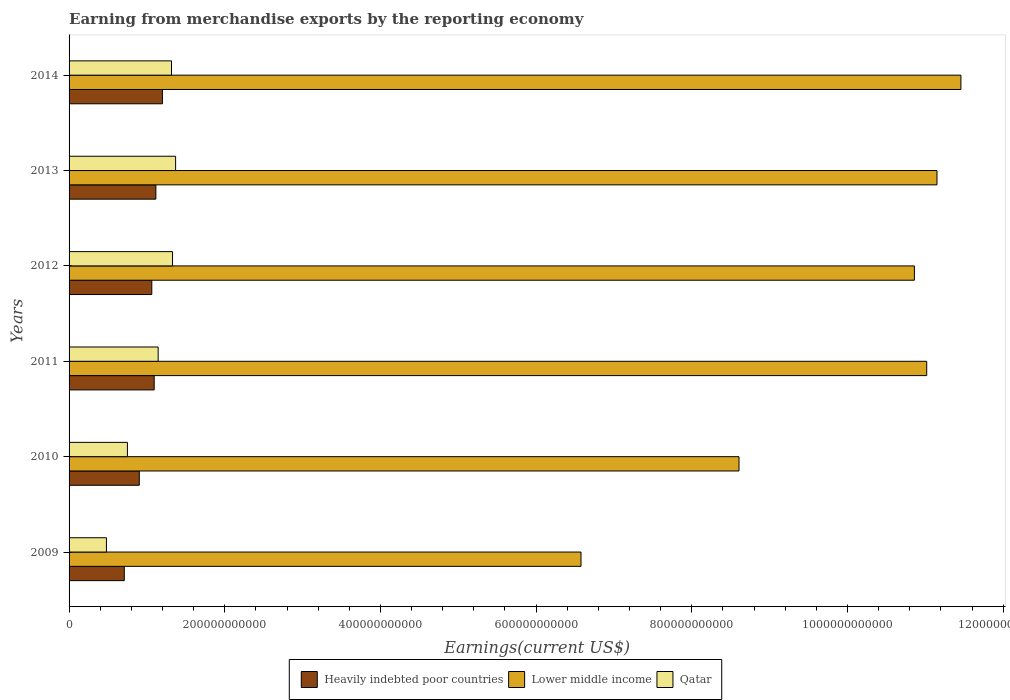How many groups of bars are there?
Offer a terse response. 6. Are the number of bars on each tick of the Y-axis equal?
Your answer should be very brief. Yes. How many bars are there on the 5th tick from the top?
Your answer should be compact. 3. In how many cases, is the number of bars for a given year not equal to the number of legend labels?
Keep it short and to the point. 0. What is the amount earned from merchandise exports in Lower middle income in 2013?
Offer a very short reply. 1.11e+12. Across all years, what is the maximum amount earned from merchandise exports in Lower middle income?
Provide a succinct answer. 1.15e+12. Across all years, what is the minimum amount earned from merchandise exports in Lower middle income?
Give a very brief answer. 6.58e+11. What is the total amount earned from merchandise exports in Lower middle income in the graph?
Keep it short and to the point. 5.97e+12. What is the difference between the amount earned from merchandise exports in Heavily indebted poor countries in 2011 and that in 2012?
Offer a very short reply. 3.08e+09. What is the difference between the amount earned from merchandise exports in Lower middle income in 2010 and the amount earned from merchandise exports in Heavily indebted poor countries in 2009?
Your answer should be compact. 7.90e+11. What is the average amount earned from merchandise exports in Qatar per year?
Your answer should be very brief. 1.06e+11. In the year 2011, what is the difference between the amount earned from merchandise exports in Lower middle income and amount earned from merchandise exports in Qatar?
Provide a succinct answer. 9.87e+11. What is the ratio of the amount earned from merchandise exports in Heavily indebted poor countries in 2013 to that in 2014?
Offer a very short reply. 0.93. Is the amount earned from merchandise exports in Lower middle income in 2011 less than that in 2013?
Make the answer very short. Yes. Is the difference between the amount earned from merchandise exports in Lower middle income in 2009 and 2012 greater than the difference between the amount earned from merchandise exports in Qatar in 2009 and 2012?
Make the answer very short. No. What is the difference between the highest and the second highest amount earned from merchandise exports in Qatar?
Provide a succinct answer. 3.96e+09. What is the difference between the highest and the lowest amount earned from merchandise exports in Qatar?
Provide a short and direct response. 8.89e+1. What does the 2nd bar from the top in 2012 represents?
Your answer should be compact. Lower middle income. What does the 1st bar from the bottom in 2013 represents?
Offer a very short reply. Heavily indebted poor countries. Is it the case that in every year, the sum of the amount earned from merchandise exports in Heavily indebted poor countries and amount earned from merchandise exports in Lower middle income is greater than the amount earned from merchandise exports in Qatar?
Offer a terse response. Yes. How many bars are there?
Keep it short and to the point. 18. What is the difference between two consecutive major ticks on the X-axis?
Offer a terse response. 2.00e+11. Where does the legend appear in the graph?
Your answer should be compact. Bottom center. What is the title of the graph?
Your response must be concise. Earning from merchandise exports by the reporting economy. Does "Brazil" appear as one of the legend labels in the graph?
Provide a succinct answer. No. What is the label or title of the X-axis?
Give a very brief answer. Earnings(current US$). What is the label or title of the Y-axis?
Provide a short and direct response. Years. What is the Earnings(current US$) of Heavily indebted poor countries in 2009?
Your response must be concise. 7.09e+1. What is the Earnings(current US$) in Lower middle income in 2009?
Keep it short and to the point. 6.58e+11. What is the Earnings(current US$) of Qatar in 2009?
Ensure brevity in your answer.  4.80e+1. What is the Earnings(current US$) of Heavily indebted poor countries in 2010?
Give a very brief answer. 9.02e+1. What is the Earnings(current US$) in Lower middle income in 2010?
Offer a very short reply. 8.61e+11. What is the Earnings(current US$) in Qatar in 2010?
Your response must be concise. 7.50e+1. What is the Earnings(current US$) in Heavily indebted poor countries in 2011?
Give a very brief answer. 1.09e+11. What is the Earnings(current US$) of Lower middle income in 2011?
Offer a terse response. 1.10e+12. What is the Earnings(current US$) in Qatar in 2011?
Your answer should be compact. 1.14e+11. What is the Earnings(current US$) in Heavily indebted poor countries in 2012?
Offer a terse response. 1.06e+11. What is the Earnings(current US$) of Lower middle income in 2012?
Your answer should be very brief. 1.09e+12. What is the Earnings(current US$) of Qatar in 2012?
Ensure brevity in your answer.  1.33e+11. What is the Earnings(current US$) in Heavily indebted poor countries in 2013?
Your answer should be compact. 1.12e+11. What is the Earnings(current US$) of Lower middle income in 2013?
Ensure brevity in your answer.  1.11e+12. What is the Earnings(current US$) in Qatar in 2013?
Ensure brevity in your answer.  1.37e+11. What is the Earnings(current US$) of Heavily indebted poor countries in 2014?
Provide a succinct answer. 1.20e+11. What is the Earnings(current US$) of Lower middle income in 2014?
Offer a terse response. 1.15e+12. What is the Earnings(current US$) in Qatar in 2014?
Ensure brevity in your answer.  1.32e+11. Across all years, what is the maximum Earnings(current US$) in Heavily indebted poor countries?
Provide a succinct answer. 1.20e+11. Across all years, what is the maximum Earnings(current US$) of Lower middle income?
Ensure brevity in your answer.  1.15e+12. Across all years, what is the maximum Earnings(current US$) of Qatar?
Offer a terse response. 1.37e+11. Across all years, what is the minimum Earnings(current US$) in Heavily indebted poor countries?
Offer a very short reply. 7.09e+1. Across all years, what is the minimum Earnings(current US$) in Lower middle income?
Your response must be concise. 6.58e+11. Across all years, what is the minimum Earnings(current US$) in Qatar?
Your response must be concise. 4.80e+1. What is the total Earnings(current US$) in Heavily indebted poor countries in the graph?
Ensure brevity in your answer.  6.08e+11. What is the total Earnings(current US$) of Lower middle income in the graph?
Your answer should be compact. 5.97e+12. What is the total Earnings(current US$) in Qatar in the graph?
Ensure brevity in your answer.  6.39e+11. What is the difference between the Earnings(current US$) of Heavily indebted poor countries in 2009 and that in 2010?
Offer a very short reply. -1.93e+1. What is the difference between the Earnings(current US$) in Lower middle income in 2009 and that in 2010?
Your answer should be compact. -2.03e+11. What is the difference between the Earnings(current US$) in Qatar in 2009 and that in 2010?
Offer a very short reply. -2.70e+1. What is the difference between the Earnings(current US$) in Heavily indebted poor countries in 2009 and that in 2011?
Your answer should be very brief. -3.84e+1. What is the difference between the Earnings(current US$) of Lower middle income in 2009 and that in 2011?
Ensure brevity in your answer.  -4.44e+11. What is the difference between the Earnings(current US$) in Qatar in 2009 and that in 2011?
Your answer should be very brief. -6.64e+1. What is the difference between the Earnings(current US$) in Heavily indebted poor countries in 2009 and that in 2012?
Ensure brevity in your answer.  -3.53e+1. What is the difference between the Earnings(current US$) of Lower middle income in 2009 and that in 2012?
Give a very brief answer. -4.28e+11. What is the difference between the Earnings(current US$) in Qatar in 2009 and that in 2012?
Provide a succinct answer. -8.49e+1. What is the difference between the Earnings(current US$) in Heavily indebted poor countries in 2009 and that in 2013?
Your response must be concise. -4.06e+1. What is the difference between the Earnings(current US$) in Lower middle income in 2009 and that in 2013?
Give a very brief answer. -4.57e+11. What is the difference between the Earnings(current US$) in Qatar in 2009 and that in 2013?
Ensure brevity in your answer.  -8.89e+1. What is the difference between the Earnings(current US$) in Heavily indebted poor countries in 2009 and that in 2014?
Your answer should be compact. -4.90e+1. What is the difference between the Earnings(current US$) in Lower middle income in 2009 and that in 2014?
Provide a succinct answer. -4.88e+11. What is the difference between the Earnings(current US$) of Qatar in 2009 and that in 2014?
Ensure brevity in your answer.  -8.36e+1. What is the difference between the Earnings(current US$) of Heavily indebted poor countries in 2010 and that in 2011?
Provide a succinct answer. -1.91e+1. What is the difference between the Earnings(current US$) in Lower middle income in 2010 and that in 2011?
Keep it short and to the point. -2.41e+11. What is the difference between the Earnings(current US$) of Qatar in 2010 and that in 2011?
Make the answer very short. -3.95e+1. What is the difference between the Earnings(current US$) of Heavily indebted poor countries in 2010 and that in 2012?
Provide a succinct answer. -1.61e+1. What is the difference between the Earnings(current US$) of Lower middle income in 2010 and that in 2012?
Offer a terse response. -2.25e+11. What is the difference between the Earnings(current US$) in Qatar in 2010 and that in 2012?
Your answer should be very brief. -5.79e+1. What is the difference between the Earnings(current US$) of Heavily indebted poor countries in 2010 and that in 2013?
Your answer should be very brief. -2.13e+1. What is the difference between the Earnings(current US$) in Lower middle income in 2010 and that in 2013?
Make the answer very short. -2.54e+11. What is the difference between the Earnings(current US$) in Qatar in 2010 and that in 2013?
Your answer should be compact. -6.19e+1. What is the difference between the Earnings(current US$) of Heavily indebted poor countries in 2010 and that in 2014?
Provide a short and direct response. -2.97e+1. What is the difference between the Earnings(current US$) in Lower middle income in 2010 and that in 2014?
Offer a very short reply. -2.85e+11. What is the difference between the Earnings(current US$) in Qatar in 2010 and that in 2014?
Offer a terse response. -5.66e+1. What is the difference between the Earnings(current US$) of Heavily indebted poor countries in 2011 and that in 2012?
Provide a short and direct response. 3.08e+09. What is the difference between the Earnings(current US$) in Lower middle income in 2011 and that in 2012?
Keep it short and to the point. 1.58e+1. What is the difference between the Earnings(current US$) in Qatar in 2011 and that in 2012?
Your answer should be compact. -1.85e+1. What is the difference between the Earnings(current US$) in Heavily indebted poor countries in 2011 and that in 2013?
Make the answer very short. -2.18e+09. What is the difference between the Earnings(current US$) of Lower middle income in 2011 and that in 2013?
Provide a short and direct response. -1.32e+1. What is the difference between the Earnings(current US$) of Qatar in 2011 and that in 2013?
Give a very brief answer. -2.24e+1. What is the difference between the Earnings(current US$) in Heavily indebted poor countries in 2011 and that in 2014?
Provide a short and direct response. -1.06e+1. What is the difference between the Earnings(current US$) of Lower middle income in 2011 and that in 2014?
Ensure brevity in your answer.  -4.39e+1. What is the difference between the Earnings(current US$) of Qatar in 2011 and that in 2014?
Make the answer very short. -1.71e+1. What is the difference between the Earnings(current US$) in Heavily indebted poor countries in 2012 and that in 2013?
Provide a succinct answer. -5.26e+09. What is the difference between the Earnings(current US$) in Lower middle income in 2012 and that in 2013?
Offer a very short reply. -2.91e+1. What is the difference between the Earnings(current US$) of Qatar in 2012 and that in 2013?
Give a very brief answer. -3.96e+09. What is the difference between the Earnings(current US$) in Heavily indebted poor countries in 2012 and that in 2014?
Provide a succinct answer. -1.37e+1. What is the difference between the Earnings(current US$) of Lower middle income in 2012 and that in 2014?
Provide a succinct answer. -5.98e+1. What is the difference between the Earnings(current US$) in Qatar in 2012 and that in 2014?
Your response must be concise. 1.32e+09. What is the difference between the Earnings(current US$) of Heavily indebted poor countries in 2013 and that in 2014?
Provide a short and direct response. -8.42e+09. What is the difference between the Earnings(current US$) in Lower middle income in 2013 and that in 2014?
Provide a succinct answer. -3.07e+1. What is the difference between the Earnings(current US$) in Qatar in 2013 and that in 2014?
Provide a short and direct response. 5.28e+09. What is the difference between the Earnings(current US$) in Heavily indebted poor countries in 2009 and the Earnings(current US$) in Lower middle income in 2010?
Your answer should be compact. -7.90e+11. What is the difference between the Earnings(current US$) in Heavily indebted poor countries in 2009 and the Earnings(current US$) in Qatar in 2010?
Give a very brief answer. -4.03e+09. What is the difference between the Earnings(current US$) of Lower middle income in 2009 and the Earnings(current US$) of Qatar in 2010?
Provide a short and direct response. 5.83e+11. What is the difference between the Earnings(current US$) of Heavily indebted poor countries in 2009 and the Earnings(current US$) of Lower middle income in 2011?
Your answer should be very brief. -1.03e+12. What is the difference between the Earnings(current US$) of Heavily indebted poor countries in 2009 and the Earnings(current US$) of Qatar in 2011?
Give a very brief answer. -4.35e+1. What is the difference between the Earnings(current US$) in Lower middle income in 2009 and the Earnings(current US$) in Qatar in 2011?
Provide a succinct answer. 5.43e+11. What is the difference between the Earnings(current US$) in Heavily indebted poor countries in 2009 and the Earnings(current US$) in Lower middle income in 2012?
Your answer should be very brief. -1.02e+12. What is the difference between the Earnings(current US$) of Heavily indebted poor countries in 2009 and the Earnings(current US$) of Qatar in 2012?
Provide a short and direct response. -6.20e+1. What is the difference between the Earnings(current US$) of Lower middle income in 2009 and the Earnings(current US$) of Qatar in 2012?
Offer a very short reply. 5.25e+11. What is the difference between the Earnings(current US$) in Heavily indebted poor countries in 2009 and the Earnings(current US$) in Lower middle income in 2013?
Your answer should be compact. -1.04e+12. What is the difference between the Earnings(current US$) of Heavily indebted poor countries in 2009 and the Earnings(current US$) of Qatar in 2013?
Your answer should be very brief. -6.59e+1. What is the difference between the Earnings(current US$) in Lower middle income in 2009 and the Earnings(current US$) in Qatar in 2013?
Provide a short and direct response. 5.21e+11. What is the difference between the Earnings(current US$) of Heavily indebted poor countries in 2009 and the Earnings(current US$) of Lower middle income in 2014?
Ensure brevity in your answer.  -1.07e+12. What is the difference between the Earnings(current US$) in Heavily indebted poor countries in 2009 and the Earnings(current US$) in Qatar in 2014?
Offer a very short reply. -6.07e+1. What is the difference between the Earnings(current US$) of Lower middle income in 2009 and the Earnings(current US$) of Qatar in 2014?
Make the answer very short. 5.26e+11. What is the difference between the Earnings(current US$) in Heavily indebted poor countries in 2010 and the Earnings(current US$) in Lower middle income in 2011?
Ensure brevity in your answer.  -1.01e+12. What is the difference between the Earnings(current US$) in Heavily indebted poor countries in 2010 and the Earnings(current US$) in Qatar in 2011?
Your answer should be compact. -2.42e+1. What is the difference between the Earnings(current US$) of Lower middle income in 2010 and the Earnings(current US$) of Qatar in 2011?
Your response must be concise. 7.46e+11. What is the difference between the Earnings(current US$) of Heavily indebted poor countries in 2010 and the Earnings(current US$) of Lower middle income in 2012?
Provide a short and direct response. -9.96e+11. What is the difference between the Earnings(current US$) of Heavily indebted poor countries in 2010 and the Earnings(current US$) of Qatar in 2012?
Your answer should be very brief. -4.27e+1. What is the difference between the Earnings(current US$) of Lower middle income in 2010 and the Earnings(current US$) of Qatar in 2012?
Your answer should be compact. 7.28e+11. What is the difference between the Earnings(current US$) in Heavily indebted poor countries in 2010 and the Earnings(current US$) in Lower middle income in 2013?
Keep it short and to the point. -1.02e+12. What is the difference between the Earnings(current US$) in Heavily indebted poor countries in 2010 and the Earnings(current US$) in Qatar in 2013?
Your response must be concise. -4.67e+1. What is the difference between the Earnings(current US$) in Lower middle income in 2010 and the Earnings(current US$) in Qatar in 2013?
Provide a succinct answer. 7.24e+11. What is the difference between the Earnings(current US$) of Heavily indebted poor countries in 2010 and the Earnings(current US$) of Lower middle income in 2014?
Ensure brevity in your answer.  -1.06e+12. What is the difference between the Earnings(current US$) in Heavily indebted poor countries in 2010 and the Earnings(current US$) in Qatar in 2014?
Ensure brevity in your answer.  -4.14e+1. What is the difference between the Earnings(current US$) of Lower middle income in 2010 and the Earnings(current US$) of Qatar in 2014?
Ensure brevity in your answer.  7.29e+11. What is the difference between the Earnings(current US$) in Heavily indebted poor countries in 2011 and the Earnings(current US$) in Lower middle income in 2012?
Give a very brief answer. -9.77e+11. What is the difference between the Earnings(current US$) in Heavily indebted poor countries in 2011 and the Earnings(current US$) in Qatar in 2012?
Give a very brief answer. -2.36e+1. What is the difference between the Earnings(current US$) in Lower middle income in 2011 and the Earnings(current US$) in Qatar in 2012?
Your response must be concise. 9.69e+11. What is the difference between the Earnings(current US$) in Heavily indebted poor countries in 2011 and the Earnings(current US$) in Lower middle income in 2013?
Ensure brevity in your answer.  -1.01e+12. What is the difference between the Earnings(current US$) of Heavily indebted poor countries in 2011 and the Earnings(current US$) of Qatar in 2013?
Keep it short and to the point. -2.75e+1. What is the difference between the Earnings(current US$) of Lower middle income in 2011 and the Earnings(current US$) of Qatar in 2013?
Ensure brevity in your answer.  9.65e+11. What is the difference between the Earnings(current US$) of Heavily indebted poor countries in 2011 and the Earnings(current US$) of Lower middle income in 2014?
Provide a succinct answer. -1.04e+12. What is the difference between the Earnings(current US$) of Heavily indebted poor countries in 2011 and the Earnings(current US$) of Qatar in 2014?
Keep it short and to the point. -2.22e+1. What is the difference between the Earnings(current US$) in Lower middle income in 2011 and the Earnings(current US$) in Qatar in 2014?
Your answer should be very brief. 9.70e+11. What is the difference between the Earnings(current US$) of Heavily indebted poor countries in 2012 and the Earnings(current US$) of Lower middle income in 2013?
Your answer should be compact. -1.01e+12. What is the difference between the Earnings(current US$) of Heavily indebted poor countries in 2012 and the Earnings(current US$) of Qatar in 2013?
Give a very brief answer. -3.06e+1. What is the difference between the Earnings(current US$) in Lower middle income in 2012 and the Earnings(current US$) in Qatar in 2013?
Provide a succinct answer. 9.49e+11. What is the difference between the Earnings(current US$) of Heavily indebted poor countries in 2012 and the Earnings(current US$) of Lower middle income in 2014?
Your answer should be very brief. -1.04e+12. What is the difference between the Earnings(current US$) of Heavily indebted poor countries in 2012 and the Earnings(current US$) of Qatar in 2014?
Your answer should be very brief. -2.53e+1. What is the difference between the Earnings(current US$) in Lower middle income in 2012 and the Earnings(current US$) in Qatar in 2014?
Ensure brevity in your answer.  9.54e+11. What is the difference between the Earnings(current US$) in Heavily indebted poor countries in 2013 and the Earnings(current US$) in Lower middle income in 2014?
Offer a terse response. -1.03e+12. What is the difference between the Earnings(current US$) of Heavily indebted poor countries in 2013 and the Earnings(current US$) of Qatar in 2014?
Offer a terse response. -2.01e+1. What is the difference between the Earnings(current US$) in Lower middle income in 2013 and the Earnings(current US$) in Qatar in 2014?
Your response must be concise. 9.83e+11. What is the average Earnings(current US$) in Heavily indebted poor countries per year?
Offer a terse response. 1.01e+11. What is the average Earnings(current US$) of Lower middle income per year?
Your response must be concise. 9.94e+11. What is the average Earnings(current US$) in Qatar per year?
Offer a terse response. 1.06e+11. In the year 2009, what is the difference between the Earnings(current US$) in Heavily indebted poor countries and Earnings(current US$) in Lower middle income?
Your response must be concise. -5.87e+11. In the year 2009, what is the difference between the Earnings(current US$) in Heavily indebted poor countries and Earnings(current US$) in Qatar?
Keep it short and to the point. 2.29e+1. In the year 2009, what is the difference between the Earnings(current US$) of Lower middle income and Earnings(current US$) of Qatar?
Offer a terse response. 6.10e+11. In the year 2010, what is the difference between the Earnings(current US$) in Heavily indebted poor countries and Earnings(current US$) in Lower middle income?
Offer a very short reply. -7.70e+11. In the year 2010, what is the difference between the Earnings(current US$) of Heavily indebted poor countries and Earnings(current US$) of Qatar?
Your response must be concise. 1.52e+1. In the year 2010, what is the difference between the Earnings(current US$) in Lower middle income and Earnings(current US$) in Qatar?
Your response must be concise. 7.86e+11. In the year 2011, what is the difference between the Earnings(current US$) in Heavily indebted poor countries and Earnings(current US$) in Lower middle income?
Your answer should be compact. -9.92e+11. In the year 2011, what is the difference between the Earnings(current US$) of Heavily indebted poor countries and Earnings(current US$) of Qatar?
Provide a short and direct response. -5.10e+09. In the year 2011, what is the difference between the Earnings(current US$) of Lower middle income and Earnings(current US$) of Qatar?
Offer a very short reply. 9.87e+11. In the year 2012, what is the difference between the Earnings(current US$) in Heavily indebted poor countries and Earnings(current US$) in Lower middle income?
Your answer should be very brief. -9.80e+11. In the year 2012, what is the difference between the Earnings(current US$) in Heavily indebted poor countries and Earnings(current US$) in Qatar?
Your response must be concise. -2.66e+1. In the year 2012, what is the difference between the Earnings(current US$) of Lower middle income and Earnings(current US$) of Qatar?
Offer a terse response. 9.53e+11. In the year 2013, what is the difference between the Earnings(current US$) in Heavily indebted poor countries and Earnings(current US$) in Lower middle income?
Provide a succinct answer. -1.00e+12. In the year 2013, what is the difference between the Earnings(current US$) in Heavily indebted poor countries and Earnings(current US$) in Qatar?
Keep it short and to the point. -2.53e+1. In the year 2013, what is the difference between the Earnings(current US$) of Lower middle income and Earnings(current US$) of Qatar?
Make the answer very short. 9.78e+11. In the year 2014, what is the difference between the Earnings(current US$) of Heavily indebted poor countries and Earnings(current US$) of Lower middle income?
Provide a short and direct response. -1.03e+12. In the year 2014, what is the difference between the Earnings(current US$) in Heavily indebted poor countries and Earnings(current US$) in Qatar?
Give a very brief answer. -1.16e+1. In the year 2014, what is the difference between the Earnings(current US$) in Lower middle income and Earnings(current US$) in Qatar?
Give a very brief answer. 1.01e+12. What is the ratio of the Earnings(current US$) of Heavily indebted poor countries in 2009 to that in 2010?
Your answer should be very brief. 0.79. What is the ratio of the Earnings(current US$) in Lower middle income in 2009 to that in 2010?
Keep it short and to the point. 0.76. What is the ratio of the Earnings(current US$) of Qatar in 2009 to that in 2010?
Keep it short and to the point. 0.64. What is the ratio of the Earnings(current US$) of Heavily indebted poor countries in 2009 to that in 2011?
Your answer should be very brief. 0.65. What is the ratio of the Earnings(current US$) of Lower middle income in 2009 to that in 2011?
Provide a succinct answer. 0.6. What is the ratio of the Earnings(current US$) in Qatar in 2009 to that in 2011?
Offer a very short reply. 0.42. What is the ratio of the Earnings(current US$) in Heavily indebted poor countries in 2009 to that in 2012?
Offer a terse response. 0.67. What is the ratio of the Earnings(current US$) in Lower middle income in 2009 to that in 2012?
Your answer should be compact. 0.61. What is the ratio of the Earnings(current US$) in Qatar in 2009 to that in 2012?
Your answer should be very brief. 0.36. What is the ratio of the Earnings(current US$) of Heavily indebted poor countries in 2009 to that in 2013?
Offer a terse response. 0.64. What is the ratio of the Earnings(current US$) of Lower middle income in 2009 to that in 2013?
Make the answer very short. 0.59. What is the ratio of the Earnings(current US$) of Qatar in 2009 to that in 2013?
Provide a short and direct response. 0.35. What is the ratio of the Earnings(current US$) in Heavily indebted poor countries in 2009 to that in 2014?
Offer a very short reply. 0.59. What is the ratio of the Earnings(current US$) in Lower middle income in 2009 to that in 2014?
Make the answer very short. 0.57. What is the ratio of the Earnings(current US$) in Qatar in 2009 to that in 2014?
Your response must be concise. 0.36. What is the ratio of the Earnings(current US$) in Heavily indebted poor countries in 2010 to that in 2011?
Give a very brief answer. 0.82. What is the ratio of the Earnings(current US$) of Lower middle income in 2010 to that in 2011?
Offer a terse response. 0.78. What is the ratio of the Earnings(current US$) in Qatar in 2010 to that in 2011?
Your answer should be very brief. 0.66. What is the ratio of the Earnings(current US$) in Heavily indebted poor countries in 2010 to that in 2012?
Offer a very short reply. 0.85. What is the ratio of the Earnings(current US$) of Lower middle income in 2010 to that in 2012?
Your answer should be compact. 0.79. What is the ratio of the Earnings(current US$) in Qatar in 2010 to that in 2012?
Offer a terse response. 0.56. What is the ratio of the Earnings(current US$) of Heavily indebted poor countries in 2010 to that in 2013?
Offer a very short reply. 0.81. What is the ratio of the Earnings(current US$) of Lower middle income in 2010 to that in 2013?
Provide a short and direct response. 0.77. What is the ratio of the Earnings(current US$) of Qatar in 2010 to that in 2013?
Ensure brevity in your answer.  0.55. What is the ratio of the Earnings(current US$) in Heavily indebted poor countries in 2010 to that in 2014?
Give a very brief answer. 0.75. What is the ratio of the Earnings(current US$) of Lower middle income in 2010 to that in 2014?
Offer a very short reply. 0.75. What is the ratio of the Earnings(current US$) of Qatar in 2010 to that in 2014?
Your response must be concise. 0.57. What is the ratio of the Earnings(current US$) of Heavily indebted poor countries in 2011 to that in 2012?
Make the answer very short. 1.03. What is the ratio of the Earnings(current US$) of Lower middle income in 2011 to that in 2012?
Provide a succinct answer. 1.01. What is the ratio of the Earnings(current US$) in Qatar in 2011 to that in 2012?
Provide a succinct answer. 0.86. What is the ratio of the Earnings(current US$) in Heavily indebted poor countries in 2011 to that in 2013?
Your answer should be compact. 0.98. What is the ratio of the Earnings(current US$) in Lower middle income in 2011 to that in 2013?
Ensure brevity in your answer.  0.99. What is the ratio of the Earnings(current US$) of Qatar in 2011 to that in 2013?
Your response must be concise. 0.84. What is the ratio of the Earnings(current US$) in Heavily indebted poor countries in 2011 to that in 2014?
Ensure brevity in your answer.  0.91. What is the ratio of the Earnings(current US$) of Lower middle income in 2011 to that in 2014?
Give a very brief answer. 0.96. What is the ratio of the Earnings(current US$) of Qatar in 2011 to that in 2014?
Offer a terse response. 0.87. What is the ratio of the Earnings(current US$) in Heavily indebted poor countries in 2012 to that in 2013?
Your answer should be compact. 0.95. What is the ratio of the Earnings(current US$) in Lower middle income in 2012 to that in 2013?
Provide a succinct answer. 0.97. What is the ratio of the Earnings(current US$) of Qatar in 2012 to that in 2013?
Your answer should be very brief. 0.97. What is the ratio of the Earnings(current US$) in Heavily indebted poor countries in 2012 to that in 2014?
Offer a very short reply. 0.89. What is the ratio of the Earnings(current US$) of Lower middle income in 2012 to that in 2014?
Ensure brevity in your answer.  0.95. What is the ratio of the Earnings(current US$) of Heavily indebted poor countries in 2013 to that in 2014?
Provide a succinct answer. 0.93. What is the ratio of the Earnings(current US$) of Lower middle income in 2013 to that in 2014?
Provide a short and direct response. 0.97. What is the ratio of the Earnings(current US$) in Qatar in 2013 to that in 2014?
Make the answer very short. 1.04. What is the difference between the highest and the second highest Earnings(current US$) in Heavily indebted poor countries?
Offer a terse response. 8.42e+09. What is the difference between the highest and the second highest Earnings(current US$) in Lower middle income?
Offer a terse response. 3.07e+1. What is the difference between the highest and the second highest Earnings(current US$) of Qatar?
Give a very brief answer. 3.96e+09. What is the difference between the highest and the lowest Earnings(current US$) of Heavily indebted poor countries?
Give a very brief answer. 4.90e+1. What is the difference between the highest and the lowest Earnings(current US$) in Lower middle income?
Your response must be concise. 4.88e+11. What is the difference between the highest and the lowest Earnings(current US$) of Qatar?
Provide a succinct answer. 8.89e+1. 